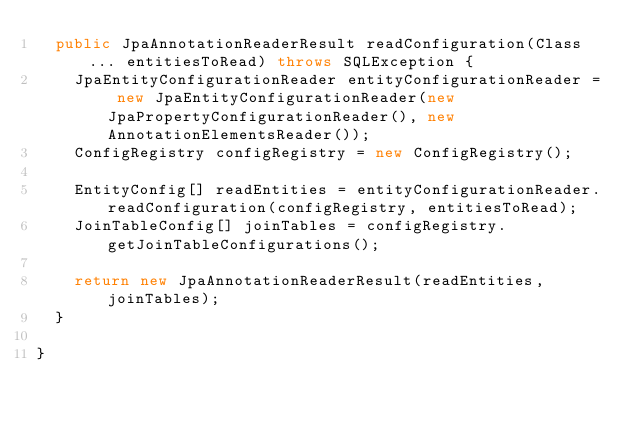Convert code to text. <code><loc_0><loc_0><loc_500><loc_500><_Java_>  public JpaAnnotationReaderResult readConfiguration(Class... entitiesToRead) throws SQLException {
    JpaEntityConfigurationReader entityConfigurationReader = new JpaEntityConfigurationReader(new JpaPropertyConfigurationReader(), new AnnotationElementsReader());
    ConfigRegistry configRegistry = new ConfigRegistry();

    EntityConfig[] readEntities = entityConfigurationReader.readConfiguration(configRegistry, entitiesToRead);
    JoinTableConfig[] joinTables = configRegistry.getJoinTableConfigurations();

    return new JpaAnnotationReaderResult(readEntities, joinTables);
  }

}
</code> 